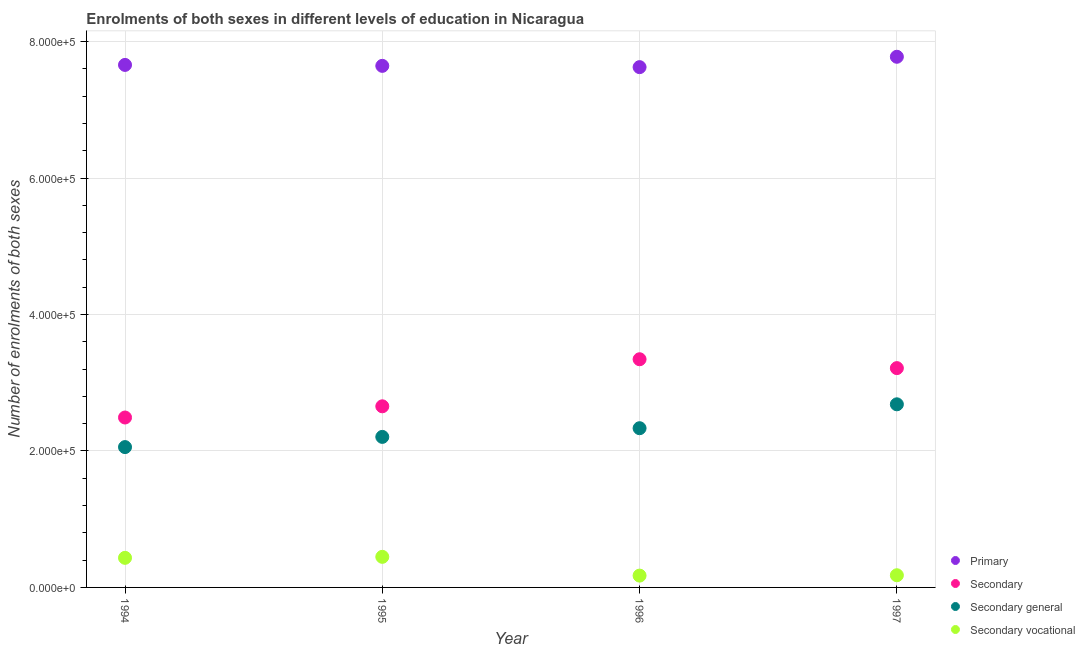How many different coloured dotlines are there?
Your answer should be very brief. 4. Is the number of dotlines equal to the number of legend labels?
Make the answer very short. Yes. What is the number of enrolments in secondary vocational education in 1996?
Keep it short and to the point. 1.73e+04. Across all years, what is the maximum number of enrolments in primary education?
Your answer should be very brief. 7.78e+05. Across all years, what is the minimum number of enrolments in secondary education?
Make the answer very short. 2.49e+05. In which year was the number of enrolments in secondary vocational education maximum?
Offer a terse response. 1995. What is the total number of enrolments in secondary general education in the graph?
Your answer should be very brief. 9.28e+05. What is the difference between the number of enrolments in secondary education in 1994 and that in 1996?
Offer a very short reply. -8.54e+04. What is the difference between the number of enrolments in secondary general education in 1997 and the number of enrolments in primary education in 1994?
Your answer should be compact. -4.98e+05. What is the average number of enrolments in secondary vocational education per year?
Make the answer very short. 3.08e+04. In the year 1997, what is the difference between the number of enrolments in primary education and number of enrolments in secondary education?
Ensure brevity in your answer.  4.56e+05. In how many years, is the number of enrolments in secondary education greater than 600000?
Provide a succinct answer. 0. What is the ratio of the number of enrolments in primary education in 1995 to that in 1997?
Your answer should be very brief. 0.98. Is the number of enrolments in secondary general education in 1994 less than that in 1997?
Give a very brief answer. Yes. Is the difference between the number of enrolments in secondary vocational education in 1995 and 1996 greater than the difference between the number of enrolments in secondary education in 1995 and 1996?
Offer a terse response. Yes. What is the difference between the highest and the second highest number of enrolments in secondary vocational education?
Give a very brief answer. 1470. What is the difference between the highest and the lowest number of enrolments in secondary general education?
Keep it short and to the point. 6.27e+04. In how many years, is the number of enrolments in primary education greater than the average number of enrolments in primary education taken over all years?
Your response must be concise. 1. Is the sum of the number of enrolments in secondary general education in 1995 and 1997 greater than the maximum number of enrolments in secondary vocational education across all years?
Offer a very short reply. Yes. Is it the case that in every year, the sum of the number of enrolments in primary education and number of enrolments in secondary vocational education is greater than the sum of number of enrolments in secondary education and number of enrolments in secondary general education?
Your response must be concise. Yes. Is it the case that in every year, the sum of the number of enrolments in primary education and number of enrolments in secondary education is greater than the number of enrolments in secondary general education?
Give a very brief answer. Yes. Is the number of enrolments in secondary education strictly less than the number of enrolments in secondary vocational education over the years?
Your response must be concise. No. How many dotlines are there?
Your response must be concise. 4. Are the values on the major ticks of Y-axis written in scientific E-notation?
Provide a short and direct response. Yes. How many legend labels are there?
Make the answer very short. 4. What is the title of the graph?
Ensure brevity in your answer.  Enrolments of both sexes in different levels of education in Nicaragua. Does "Primary schools" appear as one of the legend labels in the graph?
Make the answer very short. No. What is the label or title of the X-axis?
Give a very brief answer. Year. What is the label or title of the Y-axis?
Ensure brevity in your answer.  Number of enrolments of both sexes. What is the Number of enrolments of both sexes of Primary in 1994?
Your answer should be compact. 7.66e+05. What is the Number of enrolments of both sexes of Secondary in 1994?
Provide a succinct answer. 2.49e+05. What is the Number of enrolments of both sexes in Secondary general in 1994?
Your response must be concise. 2.06e+05. What is the Number of enrolments of both sexes in Secondary vocational in 1994?
Keep it short and to the point. 4.34e+04. What is the Number of enrolments of both sexes of Primary in 1995?
Your response must be concise. 7.65e+05. What is the Number of enrolments of both sexes of Secondary in 1995?
Keep it short and to the point. 2.66e+05. What is the Number of enrolments of both sexes in Secondary general in 1995?
Your answer should be compact. 2.21e+05. What is the Number of enrolments of both sexes in Secondary vocational in 1995?
Keep it short and to the point. 4.48e+04. What is the Number of enrolments of both sexes in Primary in 1996?
Give a very brief answer. 7.63e+05. What is the Number of enrolments of both sexes of Secondary in 1996?
Keep it short and to the point. 3.34e+05. What is the Number of enrolments of both sexes of Secondary general in 1996?
Ensure brevity in your answer.  2.33e+05. What is the Number of enrolments of both sexes of Secondary vocational in 1996?
Ensure brevity in your answer.  1.73e+04. What is the Number of enrolments of both sexes in Primary in 1997?
Your answer should be very brief. 7.78e+05. What is the Number of enrolments of both sexes of Secondary in 1997?
Provide a succinct answer. 3.21e+05. What is the Number of enrolments of both sexes of Secondary general in 1997?
Your response must be concise. 2.68e+05. What is the Number of enrolments of both sexes of Secondary vocational in 1997?
Offer a terse response. 1.79e+04. Across all years, what is the maximum Number of enrolments of both sexes of Primary?
Your answer should be compact. 7.78e+05. Across all years, what is the maximum Number of enrolments of both sexes in Secondary?
Offer a terse response. 3.34e+05. Across all years, what is the maximum Number of enrolments of both sexes of Secondary general?
Keep it short and to the point. 2.68e+05. Across all years, what is the maximum Number of enrolments of both sexes in Secondary vocational?
Offer a terse response. 4.48e+04. Across all years, what is the minimum Number of enrolments of both sexes of Primary?
Your answer should be very brief. 7.63e+05. Across all years, what is the minimum Number of enrolments of both sexes of Secondary?
Your answer should be compact. 2.49e+05. Across all years, what is the minimum Number of enrolments of both sexes in Secondary general?
Offer a very short reply. 2.06e+05. Across all years, what is the minimum Number of enrolments of both sexes in Secondary vocational?
Provide a succinct answer. 1.73e+04. What is the total Number of enrolments of both sexes in Primary in the graph?
Provide a short and direct response. 3.07e+06. What is the total Number of enrolments of both sexes in Secondary in the graph?
Offer a terse response. 1.17e+06. What is the total Number of enrolments of both sexes in Secondary general in the graph?
Provide a short and direct response. 9.28e+05. What is the total Number of enrolments of both sexes of Secondary vocational in the graph?
Your response must be concise. 1.23e+05. What is the difference between the Number of enrolments of both sexes of Primary in 1994 and that in 1995?
Make the answer very short. 1385. What is the difference between the Number of enrolments of both sexes of Secondary in 1994 and that in 1995?
Offer a terse response. -1.64e+04. What is the difference between the Number of enrolments of both sexes of Secondary general in 1994 and that in 1995?
Give a very brief answer. -1.50e+04. What is the difference between the Number of enrolments of both sexes of Secondary vocational in 1994 and that in 1995?
Make the answer very short. -1470. What is the difference between the Number of enrolments of both sexes in Primary in 1994 and that in 1996?
Make the answer very short. 3260. What is the difference between the Number of enrolments of both sexes of Secondary in 1994 and that in 1996?
Keep it short and to the point. -8.54e+04. What is the difference between the Number of enrolments of both sexes in Secondary general in 1994 and that in 1996?
Give a very brief answer. -2.77e+04. What is the difference between the Number of enrolments of both sexes of Secondary vocational in 1994 and that in 1996?
Provide a short and direct response. 2.61e+04. What is the difference between the Number of enrolments of both sexes of Primary in 1994 and that in 1997?
Give a very brief answer. -1.19e+04. What is the difference between the Number of enrolments of both sexes in Secondary in 1994 and that in 1997?
Offer a very short reply. -7.24e+04. What is the difference between the Number of enrolments of both sexes of Secondary general in 1994 and that in 1997?
Your answer should be compact. -6.27e+04. What is the difference between the Number of enrolments of both sexes of Secondary vocational in 1994 and that in 1997?
Provide a short and direct response. 2.55e+04. What is the difference between the Number of enrolments of both sexes of Primary in 1995 and that in 1996?
Offer a terse response. 1875. What is the difference between the Number of enrolments of both sexes of Secondary in 1995 and that in 1996?
Provide a short and direct response. -6.90e+04. What is the difference between the Number of enrolments of both sexes of Secondary general in 1995 and that in 1996?
Your response must be concise. -1.27e+04. What is the difference between the Number of enrolments of both sexes in Secondary vocational in 1995 and that in 1996?
Your answer should be compact. 2.75e+04. What is the difference between the Number of enrolments of both sexes of Primary in 1995 and that in 1997?
Your answer should be very brief. -1.33e+04. What is the difference between the Number of enrolments of both sexes in Secondary in 1995 and that in 1997?
Provide a succinct answer. -5.60e+04. What is the difference between the Number of enrolments of both sexes in Secondary general in 1995 and that in 1997?
Keep it short and to the point. -4.78e+04. What is the difference between the Number of enrolments of both sexes of Secondary vocational in 1995 and that in 1997?
Make the answer very short. 2.70e+04. What is the difference between the Number of enrolments of both sexes of Primary in 1996 and that in 1997?
Keep it short and to the point. -1.52e+04. What is the difference between the Number of enrolments of both sexes in Secondary in 1996 and that in 1997?
Keep it short and to the point. 1.30e+04. What is the difference between the Number of enrolments of both sexes of Secondary general in 1996 and that in 1997?
Keep it short and to the point. -3.50e+04. What is the difference between the Number of enrolments of both sexes of Secondary vocational in 1996 and that in 1997?
Make the answer very short. -532. What is the difference between the Number of enrolments of both sexes of Primary in 1994 and the Number of enrolments of both sexes of Secondary in 1995?
Your response must be concise. 5.00e+05. What is the difference between the Number of enrolments of both sexes of Primary in 1994 and the Number of enrolments of both sexes of Secondary general in 1995?
Give a very brief answer. 5.45e+05. What is the difference between the Number of enrolments of both sexes in Primary in 1994 and the Number of enrolments of both sexes in Secondary vocational in 1995?
Offer a terse response. 7.21e+05. What is the difference between the Number of enrolments of both sexes in Secondary in 1994 and the Number of enrolments of both sexes in Secondary general in 1995?
Make the answer very short. 2.84e+04. What is the difference between the Number of enrolments of both sexes in Secondary in 1994 and the Number of enrolments of both sexes in Secondary vocational in 1995?
Give a very brief answer. 2.04e+05. What is the difference between the Number of enrolments of both sexes of Secondary general in 1994 and the Number of enrolments of both sexes of Secondary vocational in 1995?
Ensure brevity in your answer.  1.61e+05. What is the difference between the Number of enrolments of both sexes in Primary in 1994 and the Number of enrolments of both sexes in Secondary in 1996?
Offer a terse response. 4.31e+05. What is the difference between the Number of enrolments of both sexes of Primary in 1994 and the Number of enrolments of both sexes of Secondary general in 1996?
Give a very brief answer. 5.33e+05. What is the difference between the Number of enrolments of both sexes in Primary in 1994 and the Number of enrolments of both sexes in Secondary vocational in 1996?
Your answer should be compact. 7.49e+05. What is the difference between the Number of enrolments of both sexes in Secondary in 1994 and the Number of enrolments of both sexes in Secondary general in 1996?
Ensure brevity in your answer.  1.57e+04. What is the difference between the Number of enrolments of both sexes of Secondary in 1994 and the Number of enrolments of both sexes of Secondary vocational in 1996?
Your answer should be very brief. 2.32e+05. What is the difference between the Number of enrolments of both sexes of Secondary general in 1994 and the Number of enrolments of both sexes of Secondary vocational in 1996?
Offer a terse response. 1.88e+05. What is the difference between the Number of enrolments of both sexes in Primary in 1994 and the Number of enrolments of both sexes in Secondary in 1997?
Give a very brief answer. 4.44e+05. What is the difference between the Number of enrolments of both sexes in Primary in 1994 and the Number of enrolments of both sexes in Secondary general in 1997?
Your answer should be compact. 4.98e+05. What is the difference between the Number of enrolments of both sexes in Primary in 1994 and the Number of enrolments of both sexes in Secondary vocational in 1997?
Your response must be concise. 7.48e+05. What is the difference between the Number of enrolments of both sexes of Secondary in 1994 and the Number of enrolments of both sexes of Secondary general in 1997?
Make the answer very short. -1.93e+04. What is the difference between the Number of enrolments of both sexes of Secondary in 1994 and the Number of enrolments of both sexes of Secondary vocational in 1997?
Give a very brief answer. 2.31e+05. What is the difference between the Number of enrolments of both sexes in Secondary general in 1994 and the Number of enrolments of both sexes in Secondary vocational in 1997?
Provide a short and direct response. 1.88e+05. What is the difference between the Number of enrolments of both sexes in Primary in 1995 and the Number of enrolments of both sexes in Secondary in 1996?
Provide a succinct answer. 4.30e+05. What is the difference between the Number of enrolments of both sexes in Primary in 1995 and the Number of enrolments of both sexes in Secondary general in 1996?
Your answer should be very brief. 5.31e+05. What is the difference between the Number of enrolments of both sexes of Primary in 1995 and the Number of enrolments of both sexes of Secondary vocational in 1996?
Your response must be concise. 7.47e+05. What is the difference between the Number of enrolments of both sexes in Secondary in 1995 and the Number of enrolments of both sexes in Secondary general in 1996?
Your answer should be very brief. 3.21e+04. What is the difference between the Number of enrolments of both sexes of Secondary in 1995 and the Number of enrolments of both sexes of Secondary vocational in 1996?
Your answer should be very brief. 2.48e+05. What is the difference between the Number of enrolments of both sexes of Secondary general in 1995 and the Number of enrolments of both sexes of Secondary vocational in 1996?
Your answer should be very brief. 2.03e+05. What is the difference between the Number of enrolments of both sexes of Primary in 1995 and the Number of enrolments of both sexes of Secondary in 1997?
Offer a terse response. 4.43e+05. What is the difference between the Number of enrolments of both sexes of Primary in 1995 and the Number of enrolments of both sexes of Secondary general in 1997?
Provide a succinct answer. 4.96e+05. What is the difference between the Number of enrolments of both sexes in Primary in 1995 and the Number of enrolments of both sexes in Secondary vocational in 1997?
Give a very brief answer. 7.47e+05. What is the difference between the Number of enrolments of both sexes of Secondary in 1995 and the Number of enrolments of both sexes of Secondary general in 1997?
Give a very brief answer. -2923. What is the difference between the Number of enrolments of both sexes in Secondary in 1995 and the Number of enrolments of both sexes in Secondary vocational in 1997?
Your answer should be very brief. 2.48e+05. What is the difference between the Number of enrolments of both sexes in Secondary general in 1995 and the Number of enrolments of both sexes in Secondary vocational in 1997?
Offer a terse response. 2.03e+05. What is the difference between the Number of enrolments of both sexes in Primary in 1996 and the Number of enrolments of both sexes in Secondary in 1997?
Your answer should be compact. 4.41e+05. What is the difference between the Number of enrolments of both sexes in Primary in 1996 and the Number of enrolments of both sexes in Secondary general in 1997?
Offer a terse response. 4.94e+05. What is the difference between the Number of enrolments of both sexes of Primary in 1996 and the Number of enrolments of both sexes of Secondary vocational in 1997?
Offer a very short reply. 7.45e+05. What is the difference between the Number of enrolments of both sexes of Secondary in 1996 and the Number of enrolments of both sexes of Secondary general in 1997?
Keep it short and to the point. 6.61e+04. What is the difference between the Number of enrolments of both sexes in Secondary in 1996 and the Number of enrolments of both sexes in Secondary vocational in 1997?
Keep it short and to the point. 3.17e+05. What is the difference between the Number of enrolments of both sexes of Secondary general in 1996 and the Number of enrolments of both sexes of Secondary vocational in 1997?
Provide a short and direct response. 2.16e+05. What is the average Number of enrolments of both sexes in Primary per year?
Offer a very short reply. 7.68e+05. What is the average Number of enrolments of both sexes in Secondary per year?
Your response must be concise. 2.93e+05. What is the average Number of enrolments of both sexes in Secondary general per year?
Provide a short and direct response. 2.32e+05. What is the average Number of enrolments of both sexes of Secondary vocational per year?
Your answer should be very brief. 3.08e+04. In the year 1994, what is the difference between the Number of enrolments of both sexes of Primary and Number of enrolments of both sexes of Secondary?
Your answer should be compact. 5.17e+05. In the year 1994, what is the difference between the Number of enrolments of both sexes of Primary and Number of enrolments of both sexes of Secondary general?
Provide a short and direct response. 5.60e+05. In the year 1994, what is the difference between the Number of enrolments of both sexes of Primary and Number of enrolments of both sexes of Secondary vocational?
Give a very brief answer. 7.23e+05. In the year 1994, what is the difference between the Number of enrolments of both sexes of Secondary and Number of enrolments of both sexes of Secondary general?
Your answer should be compact. 4.34e+04. In the year 1994, what is the difference between the Number of enrolments of both sexes in Secondary and Number of enrolments of both sexes in Secondary vocational?
Provide a short and direct response. 2.06e+05. In the year 1994, what is the difference between the Number of enrolments of both sexes of Secondary general and Number of enrolments of both sexes of Secondary vocational?
Offer a terse response. 1.62e+05. In the year 1995, what is the difference between the Number of enrolments of both sexes of Primary and Number of enrolments of both sexes of Secondary?
Make the answer very short. 4.99e+05. In the year 1995, what is the difference between the Number of enrolments of both sexes of Primary and Number of enrolments of both sexes of Secondary general?
Provide a short and direct response. 5.44e+05. In the year 1995, what is the difference between the Number of enrolments of both sexes in Primary and Number of enrolments of both sexes in Secondary vocational?
Your answer should be very brief. 7.20e+05. In the year 1995, what is the difference between the Number of enrolments of both sexes in Secondary and Number of enrolments of both sexes in Secondary general?
Make the answer very short. 4.48e+04. In the year 1995, what is the difference between the Number of enrolments of both sexes in Secondary and Number of enrolments of both sexes in Secondary vocational?
Ensure brevity in your answer.  2.21e+05. In the year 1995, what is the difference between the Number of enrolments of both sexes of Secondary general and Number of enrolments of both sexes of Secondary vocational?
Ensure brevity in your answer.  1.76e+05. In the year 1996, what is the difference between the Number of enrolments of both sexes in Primary and Number of enrolments of both sexes in Secondary?
Your response must be concise. 4.28e+05. In the year 1996, what is the difference between the Number of enrolments of both sexes of Primary and Number of enrolments of both sexes of Secondary general?
Provide a succinct answer. 5.29e+05. In the year 1996, what is the difference between the Number of enrolments of both sexes of Primary and Number of enrolments of both sexes of Secondary vocational?
Your answer should be compact. 7.45e+05. In the year 1996, what is the difference between the Number of enrolments of both sexes of Secondary and Number of enrolments of both sexes of Secondary general?
Ensure brevity in your answer.  1.01e+05. In the year 1996, what is the difference between the Number of enrolments of both sexes of Secondary and Number of enrolments of both sexes of Secondary vocational?
Your answer should be compact. 3.17e+05. In the year 1996, what is the difference between the Number of enrolments of both sexes of Secondary general and Number of enrolments of both sexes of Secondary vocational?
Offer a terse response. 2.16e+05. In the year 1997, what is the difference between the Number of enrolments of both sexes in Primary and Number of enrolments of both sexes in Secondary?
Your answer should be compact. 4.56e+05. In the year 1997, what is the difference between the Number of enrolments of both sexes in Primary and Number of enrolments of both sexes in Secondary general?
Keep it short and to the point. 5.09e+05. In the year 1997, what is the difference between the Number of enrolments of both sexes in Primary and Number of enrolments of both sexes in Secondary vocational?
Provide a short and direct response. 7.60e+05. In the year 1997, what is the difference between the Number of enrolments of both sexes of Secondary and Number of enrolments of both sexes of Secondary general?
Your response must be concise. 5.31e+04. In the year 1997, what is the difference between the Number of enrolments of both sexes in Secondary and Number of enrolments of both sexes in Secondary vocational?
Offer a very short reply. 3.04e+05. In the year 1997, what is the difference between the Number of enrolments of both sexes in Secondary general and Number of enrolments of both sexes in Secondary vocational?
Your answer should be very brief. 2.51e+05. What is the ratio of the Number of enrolments of both sexes in Secondary in 1994 to that in 1995?
Your answer should be compact. 0.94. What is the ratio of the Number of enrolments of both sexes in Secondary general in 1994 to that in 1995?
Your response must be concise. 0.93. What is the ratio of the Number of enrolments of both sexes in Secondary vocational in 1994 to that in 1995?
Your answer should be compact. 0.97. What is the ratio of the Number of enrolments of both sexes in Secondary in 1994 to that in 1996?
Your answer should be compact. 0.74. What is the ratio of the Number of enrolments of both sexes in Secondary general in 1994 to that in 1996?
Offer a terse response. 0.88. What is the ratio of the Number of enrolments of both sexes in Secondary vocational in 1994 to that in 1996?
Your answer should be compact. 2.5. What is the ratio of the Number of enrolments of both sexes of Primary in 1994 to that in 1997?
Provide a short and direct response. 0.98. What is the ratio of the Number of enrolments of both sexes of Secondary in 1994 to that in 1997?
Your response must be concise. 0.77. What is the ratio of the Number of enrolments of both sexes in Secondary general in 1994 to that in 1997?
Your response must be concise. 0.77. What is the ratio of the Number of enrolments of both sexes in Secondary vocational in 1994 to that in 1997?
Offer a terse response. 2.43. What is the ratio of the Number of enrolments of both sexes in Secondary in 1995 to that in 1996?
Provide a short and direct response. 0.79. What is the ratio of the Number of enrolments of both sexes in Secondary general in 1995 to that in 1996?
Your response must be concise. 0.95. What is the ratio of the Number of enrolments of both sexes in Secondary vocational in 1995 to that in 1996?
Give a very brief answer. 2.59. What is the ratio of the Number of enrolments of both sexes of Primary in 1995 to that in 1997?
Make the answer very short. 0.98. What is the ratio of the Number of enrolments of both sexes in Secondary in 1995 to that in 1997?
Ensure brevity in your answer.  0.83. What is the ratio of the Number of enrolments of both sexes in Secondary general in 1995 to that in 1997?
Provide a succinct answer. 0.82. What is the ratio of the Number of enrolments of both sexes of Secondary vocational in 1995 to that in 1997?
Keep it short and to the point. 2.51. What is the ratio of the Number of enrolments of both sexes of Primary in 1996 to that in 1997?
Offer a terse response. 0.98. What is the ratio of the Number of enrolments of both sexes of Secondary in 1996 to that in 1997?
Offer a terse response. 1.04. What is the ratio of the Number of enrolments of both sexes of Secondary general in 1996 to that in 1997?
Ensure brevity in your answer.  0.87. What is the ratio of the Number of enrolments of both sexes of Secondary vocational in 1996 to that in 1997?
Offer a terse response. 0.97. What is the difference between the highest and the second highest Number of enrolments of both sexes in Primary?
Your answer should be very brief. 1.19e+04. What is the difference between the highest and the second highest Number of enrolments of both sexes in Secondary?
Ensure brevity in your answer.  1.30e+04. What is the difference between the highest and the second highest Number of enrolments of both sexes of Secondary general?
Ensure brevity in your answer.  3.50e+04. What is the difference between the highest and the second highest Number of enrolments of both sexes of Secondary vocational?
Keep it short and to the point. 1470. What is the difference between the highest and the lowest Number of enrolments of both sexes in Primary?
Offer a terse response. 1.52e+04. What is the difference between the highest and the lowest Number of enrolments of both sexes in Secondary?
Ensure brevity in your answer.  8.54e+04. What is the difference between the highest and the lowest Number of enrolments of both sexes of Secondary general?
Provide a succinct answer. 6.27e+04. What is the difference between the highest and the lowest Number of enrolments of both sexes of Secondary vocational?
Provide a short and direct response. 2.75e+04. 